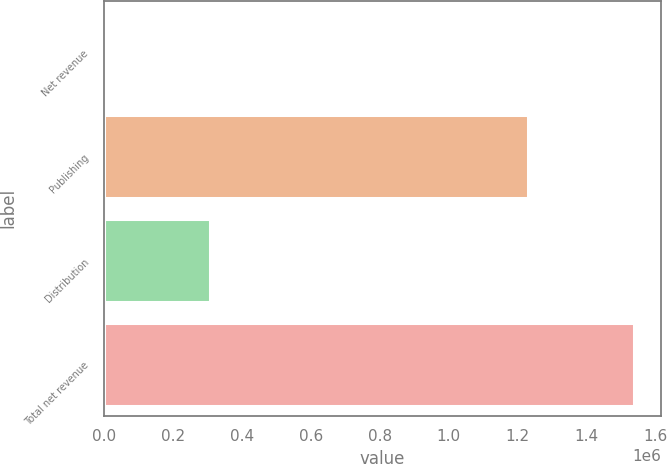<chart> <loc_0><loc_0><loc_500><loc_500><bar_chart><fcel>Net revenue<fcel>Publishing<fcel>Distribution<fcel>Total net revenue<nl><fcel>2008<fcel>1.22959e+06<fcel>307936<fcel>1.53753e+06<nl></chart> 